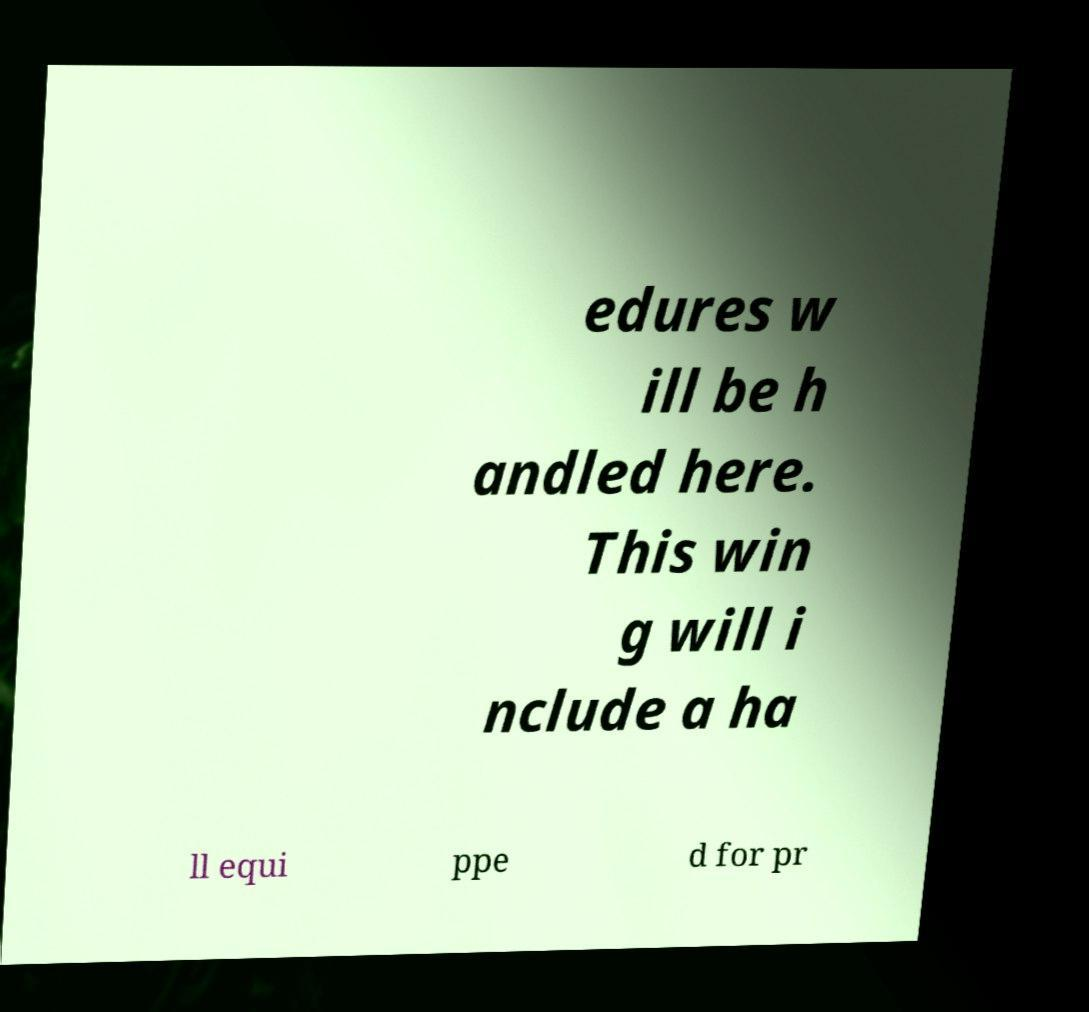Can you accurately transcribe the text from the provided image for me? edures w ill be h andled here. This win g will i nclude a ha ll equi ppe d for pr 